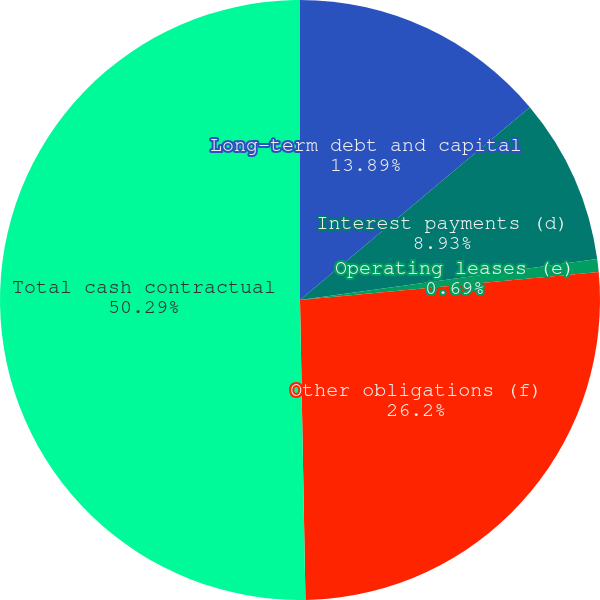<chart> <loc_0><loc_0><loc_500><loc_500><pie_chart><fcel>Long-term debt and capital<fcel>Interest payments (d)<fcel>Operating leases (e)<fcel>Other obligations (f)<fcel>Total cash contractual<nl><fcel>13.89%<fcel>8.93%<fcel>0.69%<fcel>26.2%<fcel>50.29%<nl></chart> 